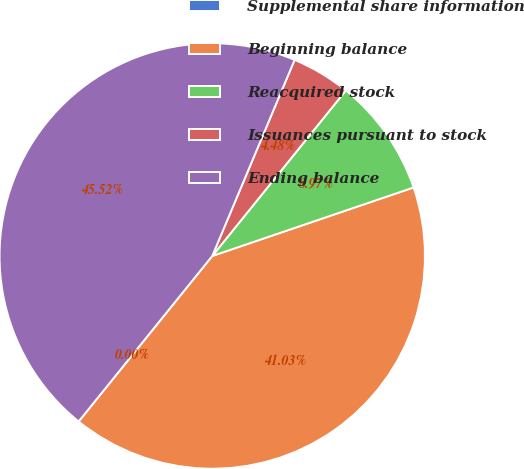Convert chart to OTSL. <chart><loc_0><loc_0><loc_500><loc_500><pie_chart><fcel>Supplemental share information<fcel>Beginning balance<fcel>Reacquired stock<fcel>Issuances pursuant to stock<fcel>Ending balance<nl><fcel>0.0%<fcel>41.03%<fcel>8.97%<fcel>4.48%<fcel>45.52%<nl></chart> 